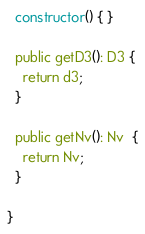Convert code to text. <code><loc_0><loc_0><loc_500><loc_500><_TypeScript_>
  constructor() { }

  public getD3(): D3 {
    return d3;
  }

  public getNv(): Nv  {
    return Nv;
  }

}
</code> 